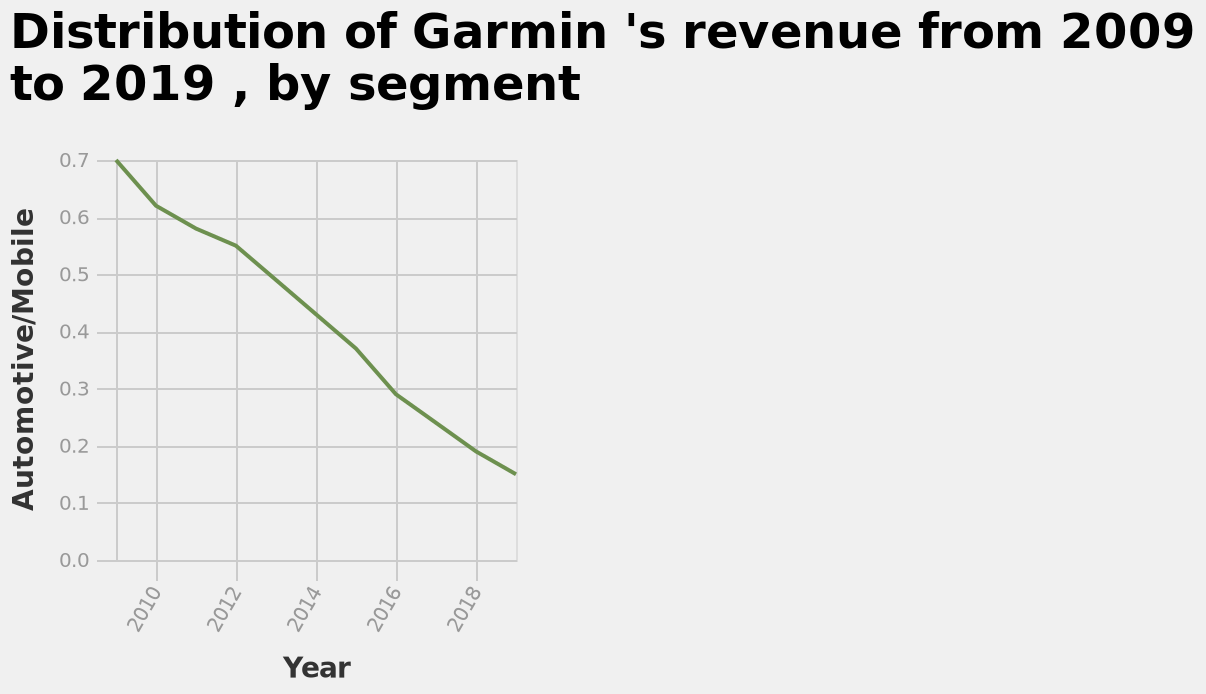<image>
Describe the following image in detail This is a line plot titled Distribution of Garmin 's revenue from 2009 to 2019 , by segment. The x-axis plots Year while the y-axis plots Automotive/Mobile. 